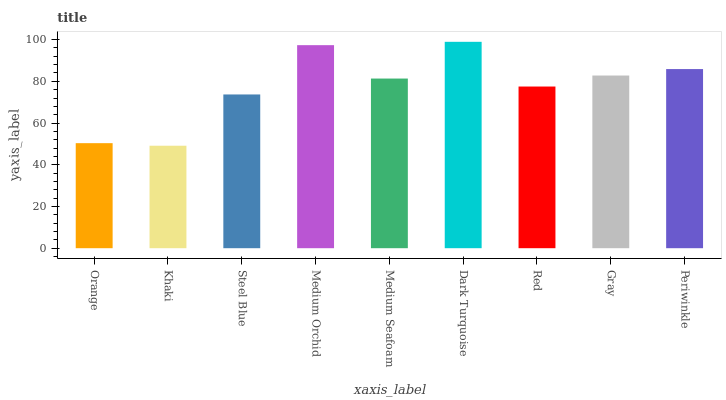Is Khaki the minimum?
Answer yes or no. Yes. Is Dark Turquoise the maximum?
Answer yes or no. Yes. Is Steel Blue the minimum?
Answer yes or no. No. Is Steel Blue the maximum?
Answer yes or no. No. Is Steel Blue greater than Khaki?
Answer yes or no. Yes. Is Khaki less than Steel Blue?
Answer yes or no. Yes. Is Khaki greater than Steel Blue?
Answer yes or no. No. Is Steel Blue less than Khaki?
Answer yes or no. No. Is Medium Seafoam the high median?
Answer yes or no. Yes. Is Medium Seafoam the low median?
Answer yes or no. Yes. Is Medium Orchid the high median?
Answer yes or no. No. Is Dark Turquoise the low median?
Answer yes or no. No. 